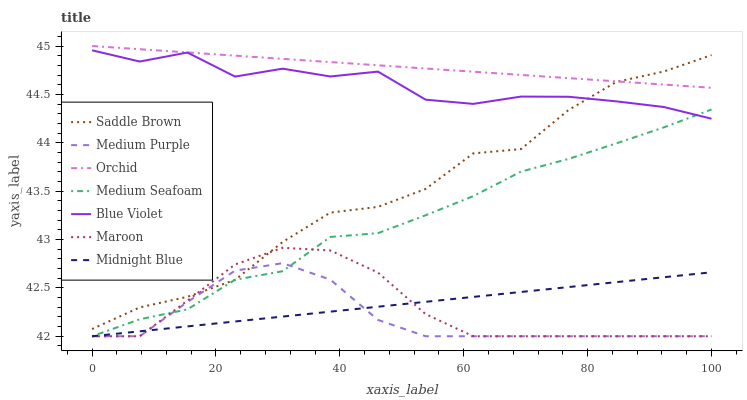Does Medium Purple have the minimum area under the curve?
Answer yes or no. Yes. Does Orchid have the maximum area under the curve?
Answer yes or no. Yes. Does Maroon have the minimum area under the curve?
Answer yes or no. No. Does Maroon have the maximum area under the curve?
Answer yes or no. No. Is Orchid the smoothest?
Answer yes or no. Yes. Is Saddle Brown the roughest?
Answer yes or no. Yes. Is Maroon the smoothest?
Answer yes or no. No. Is Maroon the roughest?
Answer yes or no. No. Does Midnight Blue have the lowest value?
Answer yes or no. Yes. Does Saddle Brown have the lowest value?
Answer yes or no. No. Does Orchid have the highest value?
Answer yes or no. Yes. Does Maroon have the highest value?
Answer yes or no. No. Is Blue Violet less than Orchid?
Answer yes or no. Yes. Is Orchid greater than Midnight Blue?
Answer yes or no. Yes. Does Saddle Brown intersect Maroon?
Answer yes or no. Yes. Is Saddle Brown less than Maroon?
Answer yes or no. No. Is Saddle Brown greater than Maroon?
Answer yes or no. No. Does Blue Violet intersect Orchid?
Answer yes or no. No. 